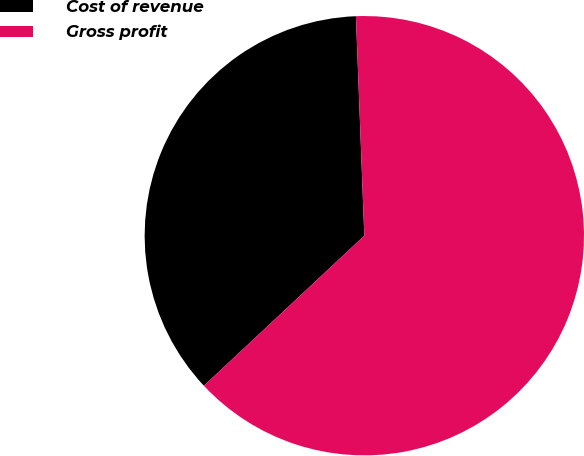<chart> <loc_0><loc_0><loc_500><loc_500><pie_chart><fcel>Cost of revenue<fcel>Gross profit<nl><fcel>36.36%<fcel>63.64%<nl></chart> 